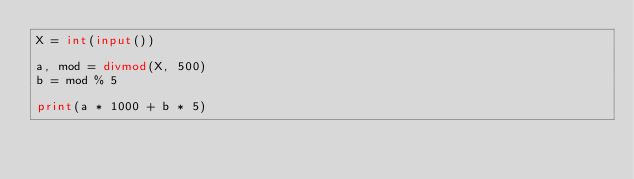Convert code to text. <code><loc_0><loc_0><loc_500><loc_500><_Python_>X = int(input())

a, mod = divmod(X, 500)
b = mod % 5

print(a * 1000 + b * 5)
</code> 